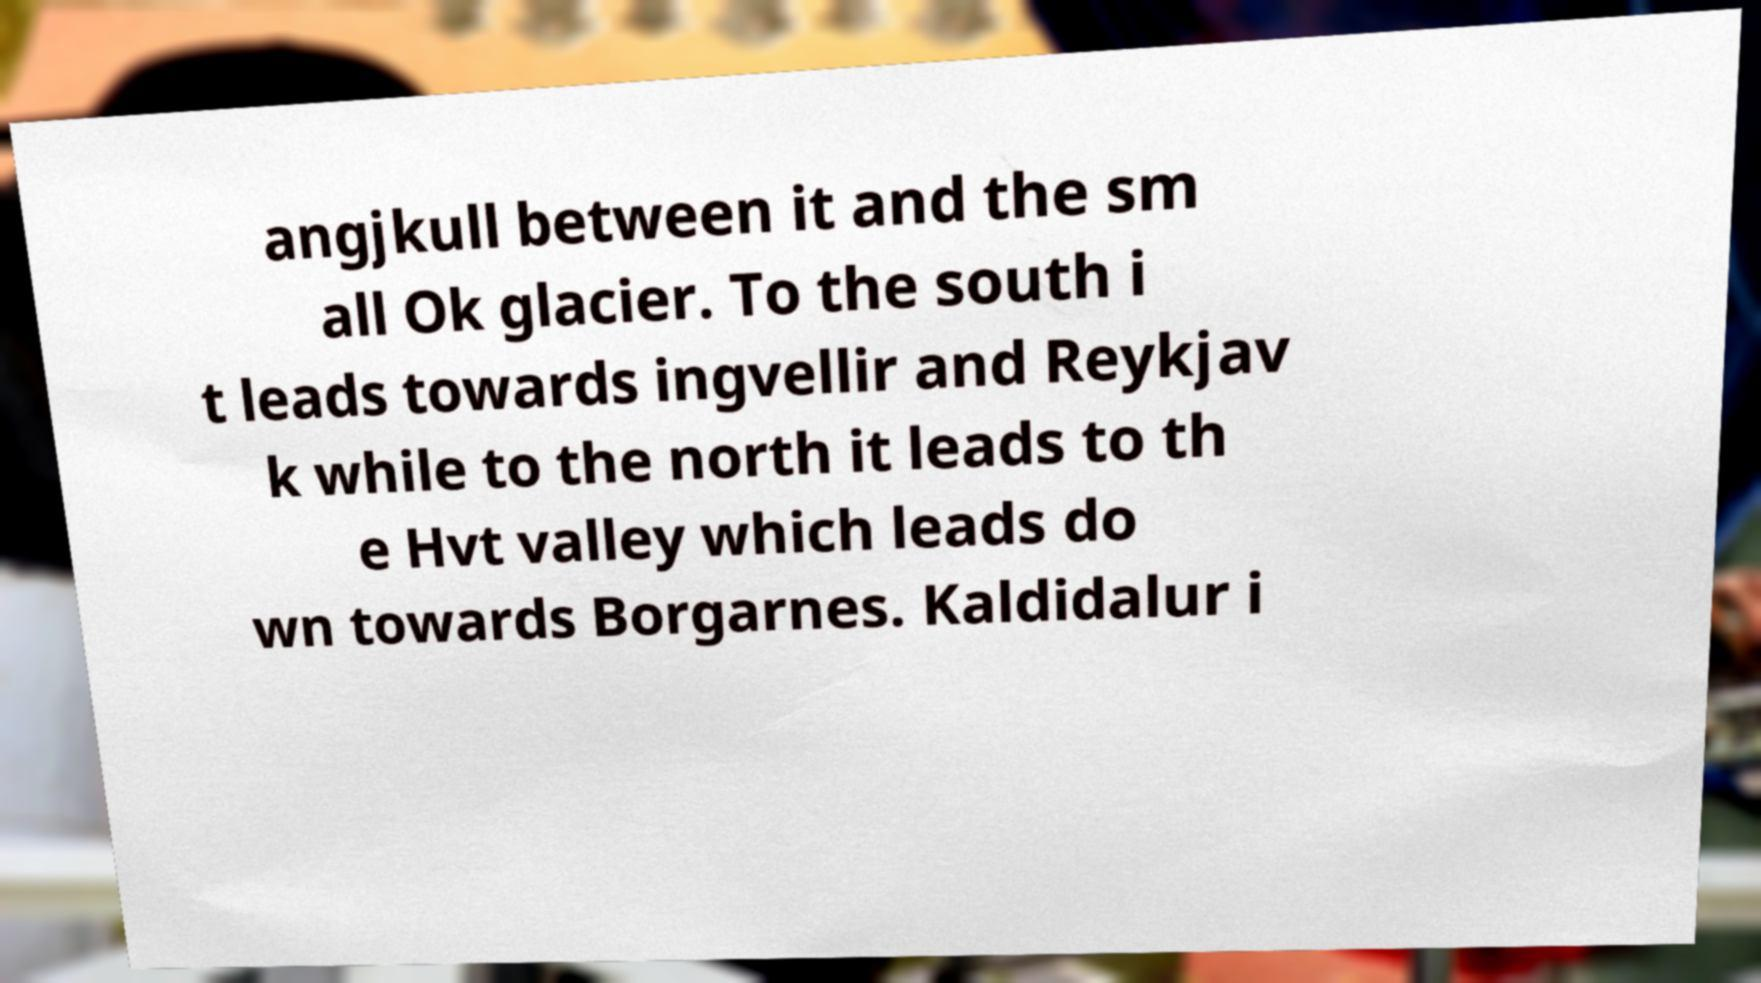Could you assist in decoding the text presented in this image and type it out clearly? angjkull between it and the sm all Ok glacier. To the south i t leads towards ingvellir and Reykjav k while to the north it leads to th e Hvt valley which leads do wn towards Borgarnes. Kaldidalur i 